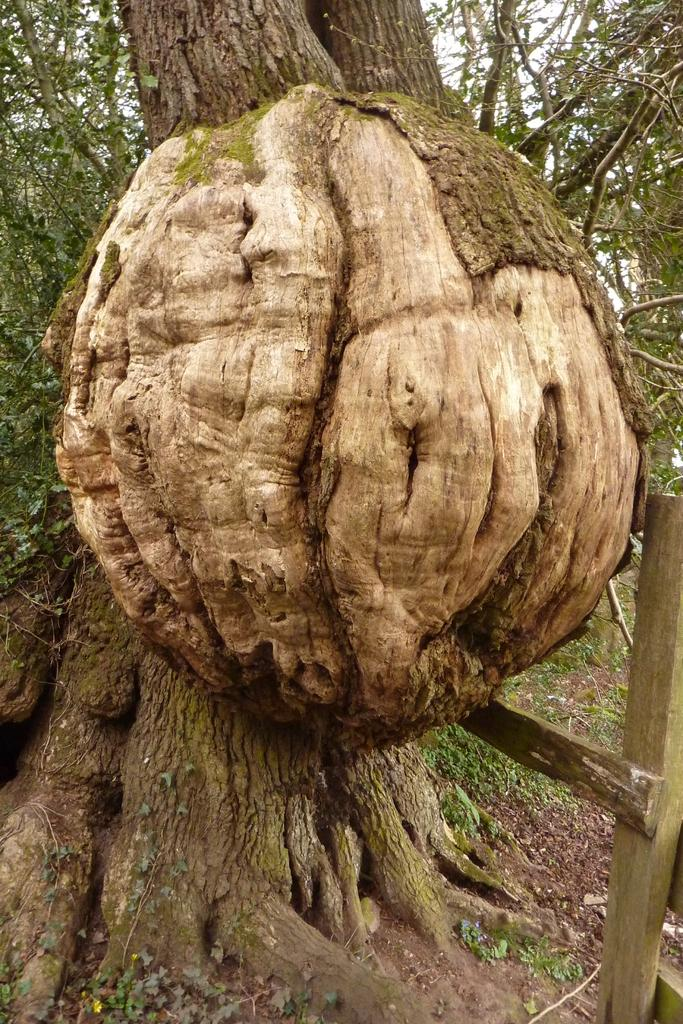What is the main subject in the image? There is a tree trunk in the image. What can be seen on the right side of the image? There is a fence on the right side of the image. What is visible in the background of the image? There are trees in the background of the image. Where are the trees located? The trees are on land. What type of rice is growing near the tree trunk in the image? There is no rice visible in the image; it features a tree trunk, a fence, and trees in the background. 